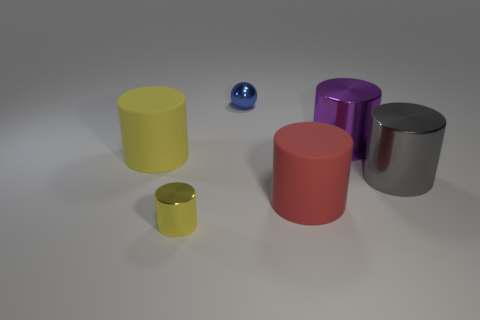How many other objects are there of the same material as the tiny yellow cylinder?
Make the answer very short. 3. Is the material of the yellow cylinder that is in front of the big yellow thing the same as the purple object?
Your response must be concise. Yes. Is the number of tiny blue objects left of the tiny yellow cylinder greater than the number of tiny yellow shiny cylinders behind the large red thing?
Ensure brevity in your answer.  No. How many objects are matte objects in front of the large gray metallic thing or small spheres?
Provide a succinct answer. 2. The gray object that is the same material as the small blue object is what shape?
Your answer should be very brief. Cylinder. Is there any other thing that is the same shape as the red object?
Ensure brevity in your answer.  Yes. What color is the metallic object that is left of the purple shiny thing and in front of the blue sphere?
Your response must be concise. Yellow. How many cylinders are blue things or yellow things?
Give a very brief answer. 2. What number of cylinders are the same size as the blue thing?
Your answer should be compact. 1. How many small blue metallic balls are to the left of the big shiny object behind the yellow matte cylinder?
Give a very brief answer. 1. 